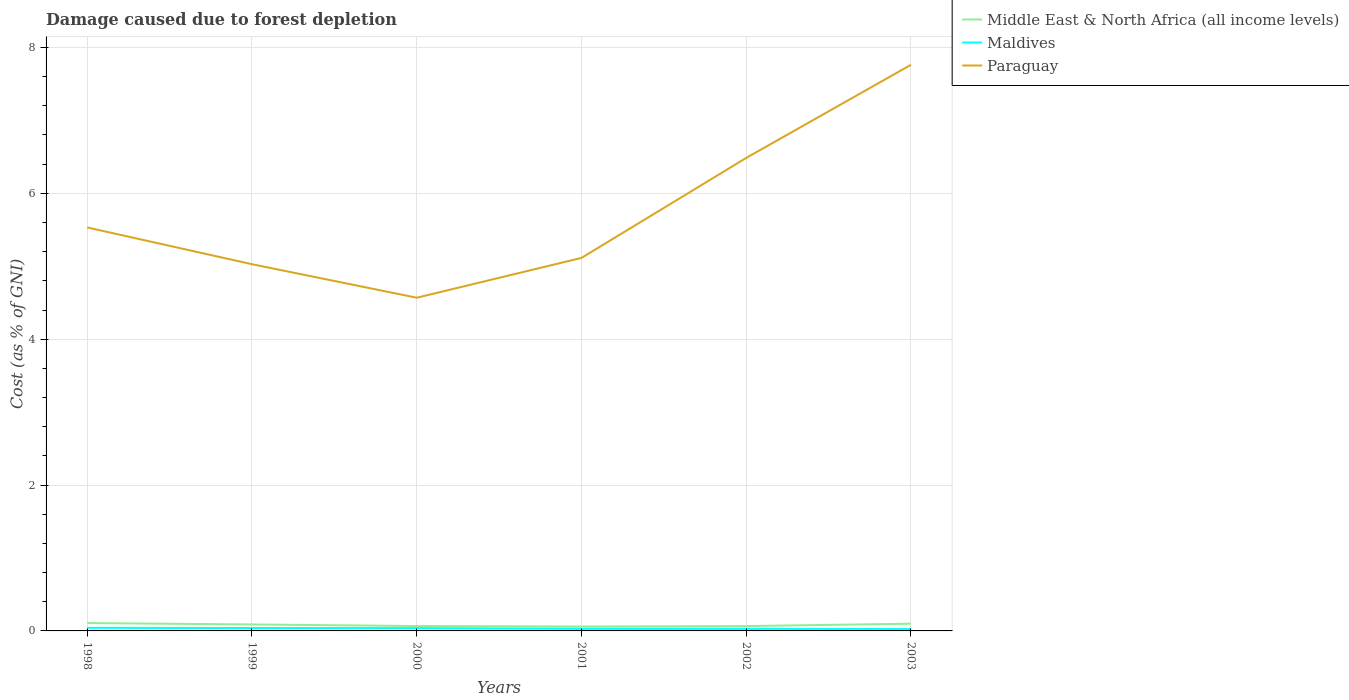Does the line corresponding to Middle East & North Africa (all income levels) intersect with the line corresponding to Maldives?
Offer a terse response. No. Across all years, what is the maximum cost of damage caused due to forest depletion in Paraguay?
Keep it short and to the point. 4.57. In which year was the cost of damage caused due to forest depletion in Paraguay maximum?
Your answer should be compact. 2000. What is the total cost of damage caused due to forest depletion in Maldives in the graph?
Offer a very short reply. 0.01. What is the difference between the highest and the second highest cost of damage caused due to forest depletion in Paraguay?
Your response must be concise. 3.19. What is the difference between the highest and the lowest cost of damage caused due to forest depletion in Middle East & North Africa (all income levels)?
Offer a very short reply. 3. Is the cost of damage caused due to forest depletion in Maldives strictly greater than the cost of damage caused due to forest depletion in Middle East & North Africa (all income levels) over the years?
Provide a succinct answer. Yes. How many lines are there?
Offer a very short reply. 3. How many years are there in the graph?
Offer a terse response. 6. Are the values on the major ticks of Y-axis written in scientific E-notation?
Your answer should be very brief. No. Does the graph contain any zero values?
Your answer should be very brief. No. Does the graph contain grids?
Give a very brief answer. Yes. How many legend labels are there?
Provide a short and direct response. 3. What is the title of the graph?
Give a very brief answer. Damage caused due to forest depletion. What is the label or title of the Y-axis?
Offer a very short reply. Cost (as % of GNI). What is the Cost (as % of GNI) in Middle East & North Africa (all income levels) in 1998?
Offer a terse response. 0.11. What is the Cost (as % of GNI) of Maldives in 1998?
Ensure brevity in your answer.  0.04. What is the Cost (as % of GNI) in Paraguay in 1998?
Offer a terse response. 5.53. What is the Cost (as % of GNI) of Middle East & North Africa (all income levels) in 1999?
Offer a terse response. 0.09. What is the Cost (as % of GNI) of Maldives in 1999?
Offer a very short reply. 0.04. What is the Cost (as % of GNI) of Paraguay in 1999?
Offer a very short reply. 5.03. What is the Cost (as % of GNI) of Middle East & North Africa (all income levels) in 2000?
Your answer should be compact. 0.07. What is the Cost (as % of GNI) in Maldives in 2000?
Your answer should be very brief. 0.04. What is the Cost (as % of GNI) of Paraguay in 2000?
Provide a short and direct response. 4.57. What is the Cost (as % of GNI) in Middle East & North Africa (all income levels) in 2001?
Provide a succinct answer. 0.06. What is the Cost (as % of GNI) in Maldives in 2001?
Ensure brevity in your answer.  0.03. What is the Cost (as % of GNI) of Paraguay in 2001?
Your response must be concise. 5.11. What is the Cost (as % of GNI) of Middle East & North Africa (all income levels) in 2002?
Offer a very short reply. 0.07. What is the Cost (as % of GNI) of Maldives in 2002?
Provide a succinct answer. 0.03. What is the Cost (as % of GNI) of Paraguay in 2002?
Provide a short and direct response. 6.49. What is the Cost (as % of GNI) of Middle East & North Africa (all income levels) in 2003?
Provide a succinct answer. 0.1. What is the Cost (as % of GNI) of Maldives in 2003?
Keep it short and to the point. 0.03. What is the Cost (as % of GNI) of Paraguay in 2003?
Your answer should be compact. 7.76. Across all years, what is the maximum Cost (as % of GNI) of Middle East & North Africa (all income levels)?
Make the answer very short. 0.11. Across all years, what is the maximum Cost (as % of GNI) in Maldives?
Your answer should be compact. 0.04. Across all years, what is the maximum Cost (as % of GNI) of Paraguay?
Offer a very short reply. 7.76. Across all years, what is the minimum Cost (as % of GNI) of Middle East & North Africa (all income levels)?
Your answer should be very brief. 0.06. Across all years, what is the minimum Cost (as % of GNI) of Maldives?
Offer a very short reply. 0.03. Across all years, what is the minimum Cost (as % of GNI) in Paraguay?
Give a very brief answer. 4.57. What is the total Cost (as % of GNI) in Middle East & North Africa (all income levels) in the graph?
Provide a short and direct response. 0.49. What is the total Cost (as % of GNI) of Maldives in the graph?
Your answer should be compact. 0.2. What is the total Cost (as % of GNI) in Paraguay in the graph?
Give a very brief answer. 34.49. What is the difference between the Cost (as % of GNI) in Middle East & North Africa (all income levels) in 1998 and that in 1999?
Ensure brevity in your answer.  0.02. What is the difference between the Cost (as % of GNI) in Maldives in 1998 and that in 1999?
Your answer should be very brief. 0. What is the difference between the Cost (as % of GNI) in Paraguay in 1998 and that in 1999?
Make the answer very short. 0.5. What is the difference between the Cost (as % of GNI) in Middle East & North Africa (all income levels) in 1998 and that in 2000?
Your answer should be compact. 0.04. What is the difference between the Cost (as % of GNI) in Maldives in 1998 and that in 2000?
Ensure brevity in your answer.  0. What is the difference between the Cost (as % of GNI) in Paraguay in 1998 and that in 2000?
Provide a short and direct response. 0.96. What is the difference between the Cost (as % of GNI) of Middle East & North Africa (all income levels) in 1998 and that in 2001?
Your answer should be compact. 0.05. What is the difference between the Cost (as % of GNI) in Maldives in 1998 and that in 2001?
Provide a succinct answer. 0.01. What is the difference between the Cost (as % of GNI) of Paraguay in 1998 and that in 2001?
Offer a terse response. 0.42. What is the difference between the Cost (as % of GNI) in Middle East & North Africa (all income levels) in 1998 and that in 2002?
Make the answer very short. 0.04. What is the difference between the Cost (as % of GNI) of Maldives in 1998 and that in 2002?
Provide a short and direct response. 0.02. What is the difference between the Cost (as % of GNI) in Paraguay in 1998 and that in 2002?
Keep it short and to the point. -0.95. What is the difference between the Cost (as % of GNI) of Middle East & North Africa (all income levels) in 1998 and that in 2003?
Offer a terse response. 0.01. What is the difference between the Cost (as % of GNI) of Maldives in 1998 and that in 2003?
Ensure brevity in your answer.  0.02. What is the difference between the Cost (as % of GNI) of Paraguay in 1998 and that in 2003?
Make the answer very short. -2.23. What is the difference between the Cost (as % of GNI) of Middle East & North Africa (all income levels) in 1999 and that in 2000?
Ensure brevity in your answer.  0.02. What is the difference between the Cost (as % of GNI) in Maldives in 1999 and that in 2000?
Make the answer very short. 0. What is the difference between the Cost (as % of GNI) of Paraguay in 1999 and that in 2000?
Your response must be concise. 0.46. What is the difference between the Cost (as % of GNI) of Middle East & North Africa (all income levels) in 1999 and that in 2001?
Offer a very short reply. 0.03. What is the difference between the Cost (as % of GNI) in Maldives in 1999 and that in 2001?
Provide a succinct answer. 0.01. What is the difference between the Cost (as % of GNI) in Paraguay in 1999 and that in 2001?
Make the answer very short. -0.09. What is the difference between the Cost (as % of GNI) of Middle East & North Africa (all income levels) in 1999 and that in 2002?
Ensure brevity in your answer.  0.02. What is the difference between the Cost (as % of GNI) of Maldives in 1999 and that in 2002?
Provide a succinct answer. 0.01. What is the difference between the Cost (as % of GNI) of Paraguay in 1999 and that in 2002?
Offer a terse response. -1.46. What is the difference between the Cost (as % of GNI) of Middle East & North Africa (all income levels) in 1999 and that in 2003?
Make the answer very short. -0.01. What is the difference between the Cost (as % of GNI) in Maldives in 1999 and that in 2003?
Provide a succinct answer. 0.01. What is the difference between the Cost (as % of GNI) of Paraguay in 1999 and that in 2003?
Make the answer very short. -2.73. What is the difference between the Cost (as % of GNI) in Middle East & North Africa (all income levels) in 2000 and that in 2001?
Ensure brevity in your answer.  0.01. What is the difference between the Cost (as % of GNI) of Maldives in 2000 and that in 2001?
Make the answer very short. 0.01. What is the difference between the Cost (as % of GNI) in Paraguay in 2000 and that in 2001?
Give a very brief answer. -0.55. What is the difference between the Cost (as % of GNI) in Middle East & North Africa (all income levels) in 2000 and that in 2002?
Your answer should be compact. 0. What is the difference between the Cost (as % of GNI) of Maldives in 2000 and that in 2002?
Keep it short and to the point. 0.01. What is the difference between the Cost (as % of GNI) in Paraguay in 2000 and that in 2002?
Make the answer very short. -1.92. What is the difference between the Cost (as % of GNI) of Middle East & North Africa (all income levels) in 2000 and that in 2003?
Give a very brief answer. -0.03. What is the difference between the Cost (as % of GNI) of Maldives in 2000 and that in 2003?
Offer a terse response. 0.01. What is the difference between the Cost (as % of GNI) of Paraguay in 2000 and that in 2003?
Give a very brief answer. -3.19. What is the difference between the Cost (as % of GNI) of Middle East & North Africa (all income levels) in 2001 and that in 2002?
Your response must be concise. -0.01. What is the difference between the Cost (as % of GNI) in Paraguay in 2001 and that in 2002?
Your answer should be compact. -1.37. What is the difference between the Cost (as % of GNI) of Middle East & North Africa (all income levels) in 2001 and that in 2003?
Make the answer very short. -0.04. What is the difference between the Cost (as % of GNI) in Maldives in 2001 and that in 2003?
Provide a succinct answer. 0. What is the difference between the Cost (as % of GNI) in Paraguay in 2001 and that in 2003?
Offer a terse response. -2.65. What is the difference between the Cost (as % of GNI) in Middle East & North Africa (all income levels) in 2002 and that in 2003?
Provide a succinct answer. -0.03. What is the difference between the Cost (as % of GNI) in Paraguay in 2002 and that in 2003?
Provide a short and direct response. -1.28. What is the difference between the Cost (as % of GNI) of Middle East & North Africa (all income levels) in 1998 and the Cost (as % of GNI) of Maldives in 1999?
Make the answer very short. 0.07. What is the difference between the Cost (as % of GNI) in Middle East & North Africa (all income levels) in 1998 and the Cost (as % of GNI) in Paraguay in 1999?
Offer a terse response. -4.92. What is the difference between the Cost (as % of GNI) in Maldives in 1998 and the Cost (as % of GNI) in Paraguay in 1999?
Ensure brevity in your answer.  -4.99. What is the difference between the Cost (as % of GNI) of Middle East & North Africa (all income levels) in 1998 and the Cost (as % of GNI) of Maldives in 2000?
Provide a succinct answer. 0.07. What is the difference between the Cost (as % of GNI) in Middle East & North Africa (all income levels) in 1998 and the Cost (as % of GNI) in Paraguay in 2000?
Offer a terse response. -4.46. What is the difference between the Cost (as % of GNI) in Maldives in 1998 and the Cost (as % of GNI) in Paraguay in 2000?
Provide a short and direct response. -4.53. What is the difference between the Cost (as % of GNI) of Middle East & North Africa (all income levels) in 1998 and the Cost (as % of GNI) of Maldives in 2001?
Offer a very short reply. 0.08. What is the difference between the Cost (as % of GNI) in Middle East & North Africa (all income levels) in 1998 and the Cost (as % of GNI) in Paraguay in 2001?
Offer a terse response. -5.01. What is the difference between the Cost (as % of GNI) in Maldives in 1998 and the Cost (as % of GNI) in Paraguay in 2001?
Your answer should be compact. -5.07. What is the difference between the Cost (as % of GNI) of Middle East & North Africa (all income levels) in 1998 and the Cost (as % of GNI) of Maldives in 2002?
Your response must be concise. 0.08. What is the difference between the Cost (as % of GNI) in Middle East & North Africa (all income levels) in 1998 and the Cost (as % of GNI) in Paraguay in 2002?
Provide a succinct answer. -6.38. What is the difference between the Cost (as % of GNI) in Maldives in 1998 and the Cost (as % of GNI) in Paraguay in 2002?
Provide a short and direct response. -6.44. What is the difference between the Cost (as % of GNI) of Middle East & North Africa (all income levels) in 1998 and the Cost (as % of GNI) of Maldives in 2003?
Your answer should be compact. 0.08. What is the difference between the Cost (as % of GNI) in Middle East & North Africa (all income levels) in 1998 and the Cost (as % of GNI) in Paraguay in 2003?
Offer a terse response. -7.65. What is the difference between the Cost (as % of GNI) in Maldives in 1998 and the Cost (as % of GNI) in Paraguay in 2003?
Give a very brief answer. -7.72. What is the difference between the Cost (as % of GNI) in Middle East & North Africa (all income levels) in 1999 and the Cost (as % of GNI) in Maldives in 2000?
Provide a succinct answer. 0.05. What is the difference between the Cost (as % of GNI) of Middle East & North Africa (all income levels) in 1999 and the Cost (as % of GNI) of Paraguay in 2000?
Offer a very short reply. -4.48. What is the difference between the Cost (as % of GNI) in Maldives in 1999 and the Cost (as % of GNI) in Paraguay in 2000?
Offer a terse response. -4.53. What is the difference between the Cost (as % of GNI) of Middle East & North Africa (all income levels) in 1999 and the Cost (as % of GNI) of Maldives in 2001?
Provide a short and direct response. 0.06. What is the difference between the Cost (as % of GNI) of Middle East & North Africa (all income levels) in 1999 and the Cost (as % of GNI) of Paraguay in 2001?
Your answer should be very brief. -5.03. What is the difference between the Cost (as % of GNI) of Maldives in 1999 and the Cost (as % of GNI) of Paraguay in 2001?
Keep it short and to the point. -5.07. What is the difference between the Cost (as % of GNI) of Middle East & North Africa (all income levels) in 1999 and the Cost (as % of GNI) of Maldives in 2002?
Make the answer very short. 0.06. What is the difference between the Cost (as % of GNI) of Middle East & North Africa (all income levels) in 1999 and the Cost (as % of GNI) of Paraguay in 2002?
Keep it short and to the point. -6.4. What is the difference between the Cost (as % of GNI) of Maldives in 1999 and the Cost (as % of GNI) of Paraguay in 2002?
Make the answer very short. -6.45. What is the difference between the Cost (as % of GNI) in Middle East & North Africa (all income levels) in 1999 and the Cost (as % of GNI) in Maldives in 2003?
Keep it short and to the point. 0.06. What is the difference between the Cost (as % of GNI) of Middle East & North Africa (all income levels) in 1999 and the Cost (as % of GNI) of Paraguay in 2003?
Provide a short and direct response. -7.67. What is the difference between the Cost (as % of GNI) of Maldives in 1999 and the Cost (as % of GNI) of Paraguay in 2003?
Offer a very short reply. -7.72. What is the difference between the Cost (as % of GNI) in Middle East & North Africa (all income levels) in 2000 and the Cost (as % of GNI) in Maldives in 2001?
Offer a terse response. 0.04. What is the difference between the Cost (as % of GNI) of Middle East & North Africa (all income levels) in 2000 and the Cost (as % of GNI) of Paraguay in 2001?
Provide a succinct answer. -5.05. What is the difference between the Cost (as % of GNI) in Maldives in 2000 and the Cost (as % of GNI) in Paraguay in 2001?
Offer a very short reply. -5.08. What is the difference between the Cost (as % of GNI) of Middle East & North Africa (all income levels) in 2000 and the Cost (as % of GNI) of Maldives in 2002?
Provide a succinct answer. 0.04. What is the difference between the Cost (as % of GNI) of Middle East & North Africa (all income levels) in 2000 and the Cost (as % of GNI) of Paraguay in 2002?
Offer a terse response. -6.42. What is the difference between the Cost (as % of GNI) of Maldives in 2000 and the Cost (as % of GNI) of Paraguay in 2002?
Make the answer very short. -6.45. What is the difference between the Cost (as % of GNI) of Middle East & North Africa (all income levels) in 2000 and the Cost (as % of GNI) of Maldives in 2003?
Offer a very short reply. 0.04. What is the difference between the Cost (as % of GNI) of Middle East & North Africa (all income levels) in 2000 and the Cost (as % of GNI) of Paraguay in 2003?
Give a very brief answer. -7.7. What is the difference between the Cost (as % of GNI) in Maldives in 2000 and the Cost (as % of GNI) in Paraguay in 2003?
Ensure brevity in your answer.  -7.72. What is the difference between the Cost (as % of GNI) in Middle East & North Africa (all income levels) in 2001 and the Cost (as % of GNI) in Maldives in 2002?
Ensure brevity in your answer.  0.03. What is the difference between the Cost (as % of GNI) in Middle East & North Africa (all income levels) in 2001 and the Cost (as % of GNI) in Paraguay in 2002?
Provide a short and direct response. -6.43. What is the difference between the Cost (as % of GNI) of Maldives in 2001 and the Cost (as % of GNI) of Paraguay in 2002?
Give a very brief answer. -6.46. What is the difference between the Cost (as % of GNI) of Middle East & North Africa (all income levels) in 2001 and the Cost (as % of GNI) of Maldives in 2003?
Make the answer very short. 0.03. What is the difference between the Cost (as % of GNI) of Middle East & North Africa (all income levels) in 2001 and the Cost (as % of GNI) of Paraguay in 2003?
Keep it short and to the point. -7.7. What is the difference between the Cost (as % of GNI) in Maldives in 2001 and the Cost (as % of GNI) in Paraguay in 2003?
Keep it short and to the point. -7.73. What is the difference between the Cost (as % of GNI) in Middle East & North Africa (all income levels) in 2002 and the Cost (as % of GNI) in Maldives in 2003?
Offer a very short reply. 0.04. What is the difference between the Cost (as % of GNI) of Middle East & North Africa (all income levels) in 2002 and the Cost (as % of GNI) of Paraguay in 2003?
Make the answer very short. -7.7. What is the difference between the Cost (as % of GNI) in Maldives in 2002 and the Cost (as % of GNI) in Paraguay in 2003?
Provide a succinct answer. -7.74. What is the average Cost (as % of GNI) in Middle East & North Africa (all income levels) per year?
Give a very brief answer. 0.08. What is the average Cost (as % of GNI) of Maldives per year?
Provide a succinct answer. 0.03. What is the average Cost (as % of GNI) in Paraguay per year?
Give a very brief answer. 5.75. In the year 1998, what is the difference between the Cost (as % of GNI) in Middle East & North Africa (all income levels) and Cost (as % of GNI) in Maldives?
Offer a terse response. 0.07. In the year 1998, what is the difference between the Cost (as % of GNI) in Middle East & North Africa (all income levels) and Cost (as % of GNI) in Paraguay?
Ensure brevity in your answer.  -5.42. In the year 1998, what is the difference between the Cost (as % of GNI) of Maldives and Cost (as % of GNI) of Paraguay?
Ensure brevity in your answer.  -5.49. In the year 1999, what is the difference between the Cost (as % of GNI) in Middle East & North Africa (all income levels) and Cost (as % of GNI) in Maldives?
Provide a short and direct response. 0.05. In the year 1999, what is the difference between the Cost (as % of GNI) of Middle East & North Africa (all income levels) and Cost (as % of GNI) of Paraguay?
Provide a succinct answer. -4.94. In the year 1999, what is the difference between the Cost (as % of GNI) in Maldives and Cost (as % of GNI) in Paraguay?
Offer a very short reply. -4.99. In the year 2000, what is the difference between the Cost (as % of GNI) of Middle East & North Africa (all income levels) and Cost (as % of GNI) of Maldives?
Provide a succinct answer. 0.03. In the year 2000, what is the difference between the Cost (as % of GNI) of Middle East & North Africa (all income levels) and Cost (as % of GNI) of Paraguay?
Offer a terse response. -4.5. In the year 2000, what is the difference between the Cost (as % of GNI) in Maldives and Cost (as % of GNI) in Paraguay?
Offer a very short reply. -4.53. In the year 2001, what is the difference between the Cost (as % of GNI) in Middle East & North Africa (all income levels) and Cost (as % of GNI) in Maldives?
Ensure brevity in your answer.  0.03. In the year 2001, what is the difference between the Cost (as % of GNI) of Middle East & North Africa (all income levels) and Cost (as % of GNI) of Paraguay?
Provide a succinct answer. -5.05. In the year 2001, what is the difference between the Cost (as % of GNI) in Maldives and Cost (as % of GNI) in Paraguay?
Offer a terse response. -5.09. In the year 2002, what is the difference between the Cost (as % of GNI) in Middle East & North Africa (all income levels) and Cost (as % of GNI) in Maldives?
Ensure brevity in your answer.  0.04. In the year 2002, what is the difference between the Cost (as % of GNI) in Middle East & North Africa (all income levels) and Cost (as % of GNI) in Paraguay?
Keep it short and to the point. -6.42. In the year 2002, what is the difference between the Cost (as % of GNI) in Maldives and Cost (as % of GNI) in Paraguay?
Give a very brief answer. -6.46. In the year 2003, what is the difference between the Cost (as % of GNI) of Middle East & North Africa (all income levels) and Cost (as % of GNI) of Maldives?
Offer a terse response. 0.07. In the year 2003, what is the difference between the Cost (as % of GNI) in Middle East & North Africa (all income levels) and Cost (as % of GNI) in Paraguay?
Provide a succinct answer. -7.66. In the year 2003, what is the difference between the Cost (as % of GNI) of Maldives and Cost (as % of GNI) of Paraguay?
Ensure brevity in your answer.  -7.74. What is the ratio of the Cost (as % of GNI) in Middle East & North Africa (all income levels) in 1998 to that in 1999?
Ensure brevity in your answer.  1.21. What is the ratio of the Cost (as % of GNI) of Maldives in 1998 to that in 1999?
Make the answer very short. 1.07. What is the ratio of the Cost (as % of GNI) in Paraguay in 1998 to that in 1999?
Provide a short and direct response. 1.1. What is the ratio of the Cost (as % of GNI) in Middle East & North Africa (all income levels) in 1998 to that in 2000?
Offer a terse response. 1.6. What is the ratio of the Cost (as % of GNI) of Maldives in 1998 to that in 2000?
Keep it short and to the point. 1.09. What is the ratio of the Cost (as % of GNI) of Paraguay in 1998 to that in 2000?
Ensure brevity in your answer.  1.21. What is the ratio of the Cost (as % of GNI) of Middle East & North Africa (all income levels) in 1998 to that in 2001?
Offer a terse response. 1.8. What is the ratio of the Cost (as % of GNI) of Maldives in 1998 to that in 2001?
Your answer should be very brief. 1.53. What is the ratio of the Cost (as % of GNI) in Paraguay in 1998 to that in 2001?
Your answer should be compact. 1.08. What is the ratio of the Cost (as % of GNI) of Middle East & North Africa (all income levels) in 1998 to that in 2002?
Ensure brevity in your answer.  1.62. What is the ratio of the Cost (as % of GNI) in Maldives in 1998 to that in 2002?
Give a very brief answer. 1.55. What is the ratio of the Cost (as % of GNI) in Paraguay in 1998 to that in 2002?
Make the answer very short. 0.85. What is the ratio of the Cost (as % of GNI) of Middle East & North Africa (all income levels) in 1998 to that in 2003?
Your response must be concise. 1.09. What is the ratio of the Cost (as % of GNI) of Maldives in 1998 to that in 2003?
Your answer should be very brief. 1.58. What is the ratio of the Cost (as % of GNI) of Paraguay in 1998 to that in 2003?
Your answer should be compact. 0.71. What is the ratio of the Cost (as % of GNI) in Middle East & North Africa (all income levels) in 1999 to that in 2000?
Your response must be concise. 1.32. What is the ratio of the Cost (as % of GNI) of Maldives in 1999 to that in 2000?
Give a very brief answer. 1.02. What is the ratio of the Cost (as % of GNI) of Paraguay in 1999 to that in 2000?
Offer a terse response. 1.1. What is the ratio of the Cost (as % of GNI) of Middle East & North Africa (all income levels) in 1999 to that in 2001?
Offer a very short reply. 1.48. What is the ratio of the Cost (as % of GNI) in Maldives in 1999 to that in 2001?
Offer a terse response. 1.42. What is the ratio of the Cost (as % of GNI) of Paraguay in 1999 to that in 2001?
Keep it short and to the point. 0.98. What is the ratio of the Cost (as % of GNI) of Middle East & North Africa (all income levels) in 1999 to that in 2002?
Offer a very short reply. 1.33. What is the ratio of the Cost (as % of GNI) in Maldives in 1999 to that in 2002?
Offer a terse response. 1.45. What is the ratio of the Cost (as % of GNI) in Paraguay in 1999 to that in 2002?
Your answer should be compact. 0.78. What is the ratio of the Cost (as % of GNI) in Middle East & North Africa (all income levels) in 1999 to that in 2003?
Offer a terse response. 0.9. What is the ratio of the Cost (as % of GNI) in Maldives in 1999 to that in 2003?
Make the answer very short. 1.47. What is the ratio of the Cost (as % of GNI) of Paraguay in 1999 to that in 2003?
Keep it short and to the point. 0.65. What is the ratio of the Cost (as % of GNI) in Middle East & North Africa (all income levels) in 2000 to that in 2001?
Offer a terse response. 1.12. What is the ratio of the Cost (as % of GNI) in Maldives in 2000 to that in 2001?
Provide a short and direct response. 1.4. What is the ratio of the Cost (as % of GNI) of Paraguay in 2000 to that in 2001?
Offer a very short reply. 0.89. What is the ratio of the Cost (as % of GNI) in Middle East & North Africa (all income levels) in 2000 to that in 2002?
Provide a succinct answer. 1.01. What is the ratio of the Cost (as % of GNI) in Maldives in 2000 to that in 2002?
Offer a terse response. 1.42. What is the ratio of the Cost (as % of GNI) of Paraguay in 2000 to that in 2002?
Give a very brief answer. 0.7. What is the ratio of the Cost (as % of GNI) of Middle East & North Africa (all income levels) in 2000 to that in 2003?
Offer a terse response. 0.68. What is the ratio of the Cost (as % of GNI) of Maldives in 2000 to that in 2003?
Give a very brief answer. 1.45. What is the ratio of the Cost (as % of GNI) in Paraguay in 2000 to that in 2003?
Your response must be concise. 0.59. What is the ratio of the Cost (as % of GNI) of Middle East & North Africa (all income levels) in 2001 to that in 2002?
Your response must be concise. 0.9. What is the ratio of the Cost (as % of GNI) of Maldives in 2001 to that in 2002?
Offer a very short reply. 1.02. What is the ratio of the Cost (as % of GNI) in Paraguay in 2001 to that in 2002?
Give a very brief answer. 0.79. What is the ratio of the Cost (as % of GNI) of Middle East & North Africa (all income levels) in 2001 to that in 2003?
Offer a terse response. 0.6. What is the ratio of the Cost (as % of GNI) in Maldives in 2001 to that in 2003?
Offer a very short reply. 1.04. What is the ratio of the Cost (as % of GNI) of Paraguay in 2001 to that in 2003?
Make the answer very short. 0.66. What is the ratio of the Cost (as % of GNI) in Middle East & North Africa (all income levels) in 2002 to that in 2003?
Provide a succinct answer. 0.67. What is the ratio of the Cost (as % of GNI) in Maldives in 2002 to that in 2003?
Your answer should be very brief. 1.02. What is the ratio of the Cost (as % of GNI) in Paraguay in 2002 to that in 2003?
Provide a short and direct response. 0.84. What is the difference between the highest and the second highest Cost (as % of GNI) in Middle East & North Africa (all income levels)?
Your answer should be compact. 0.01. What is the difference between the highest and the second highest Cost (as % of GNI) in Maldives?
Make the answer very short. 0. What is the difference between the highest and the second highest Cost (as % of GNI) of Paraguay?
Keep it short and to the point. 1.28. What is the difference between the highest and the lowest Cost (as % of GNI) of Middle East & North Africa (all income levels)?
Provide a succinct answer. 0.05. What is the difference between the highest and the lowest Cost (as % of GNI) in Maldives?
Your response must be concise. 0.02. What is the difference between the highest and the lowest Cost (as % of GNI) in Paraguay?
Provide a short and direct response. 3.19. 